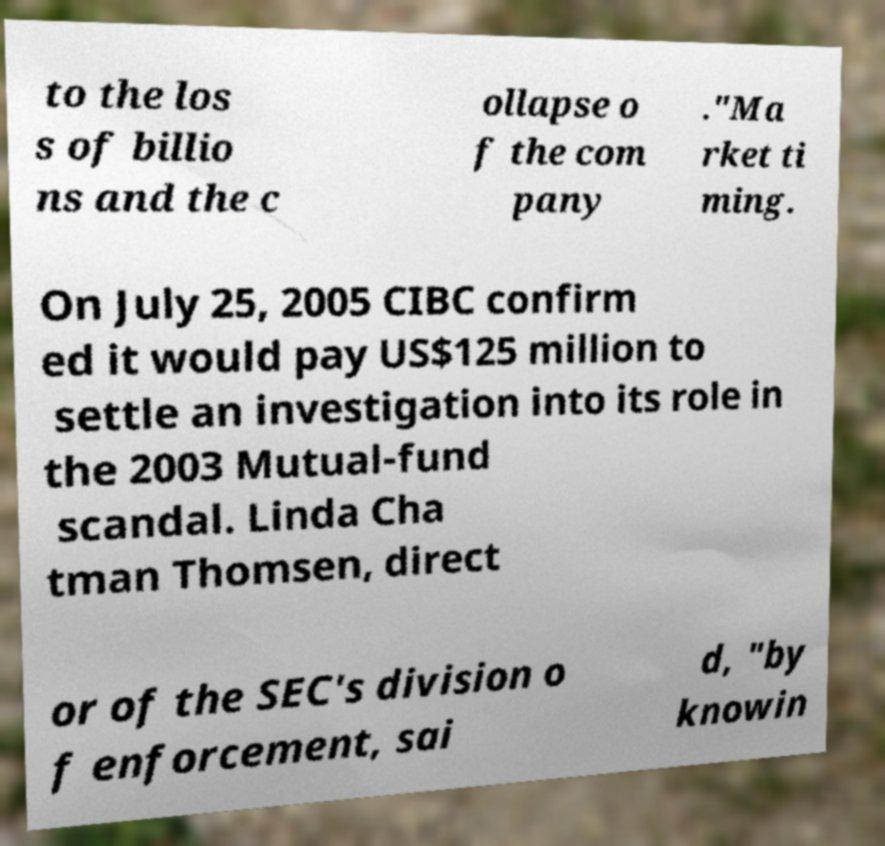Could you extract and type out the text from this image? to the los s of billio ns and the c ollapse o f the com pany ."Ma rket ti ming. On July 25, 2005 CIBC confirm ed it would pay US$125 million to settle an investigation into its role in the 2003 Mutual-fund scandal. Linda Cha tman Thomsen, direct or of the SEC's division o f enforcement, sai d, "by knowin 